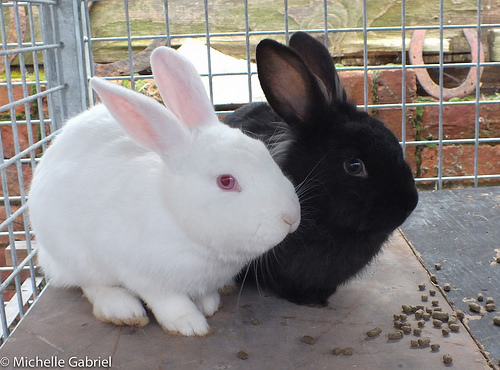<image>
Is there a black bunny behind the white bunny? No. The black bunny is not behind the white bunny. From this viewpoint, the black bunny appears to be positioned elsewhere in the scene. Where is the white rabbit in relation to the black rabbit? Is it to the left of the black rabbit? Yes. From this viewpoint, the white rabbit is positioned to the left side relative to the black rabbit. 